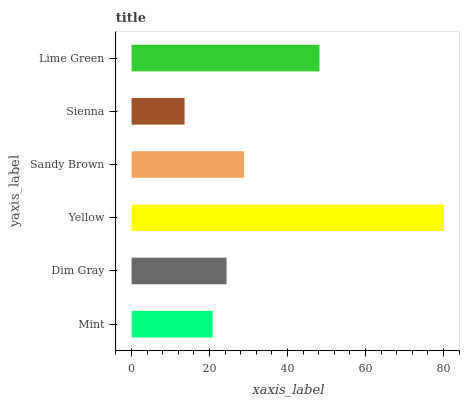Is Sienna the minimum?
Answer yes or no. Yes. Is Yellow the maximum?
Answer yes or no. Yes. Is Dim Gray the minimum?
Answer yes or no. No. Is Dim Gray the maximum?
Answer yes or no. No. Is Dim Gray greater than Mint?
Answer yes or no. Yes. Is Mint less than Dim Gray?
Answer yes or no. Yes. Is Mint greater than Dim Gray?
Answer yes or no. No. Is Dim Gray less than Mint?
Answer yes or no. No. Is Sandy Brown the high median?
Answer yes or no. Yes. Is Dim Gray the low median?
Answer yes or no. Yes. Is Yellow the high median?
Answer yes or no. No. Is Sandy Brown the low median?
Answer yes or no. No. 